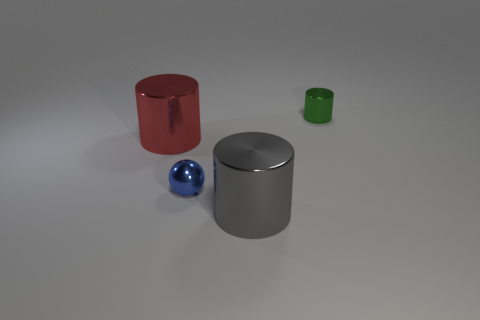Subtract all big cylinders. How many cylinders are left? 1 Add 2 large metal objects. How many objects exist? 6 Subtract all balls. How many objects are left? 3 Add 3 big gray things. How many big gray things exist? 4 Subtract 1 green cylinders. How many objects are left? 3 Subtract all big red metal things. Subtract all blue things. How many objects are left? 2 Add 1 tiny blue shiny spheres. How many tiny blue shiny spheres are left? 2 